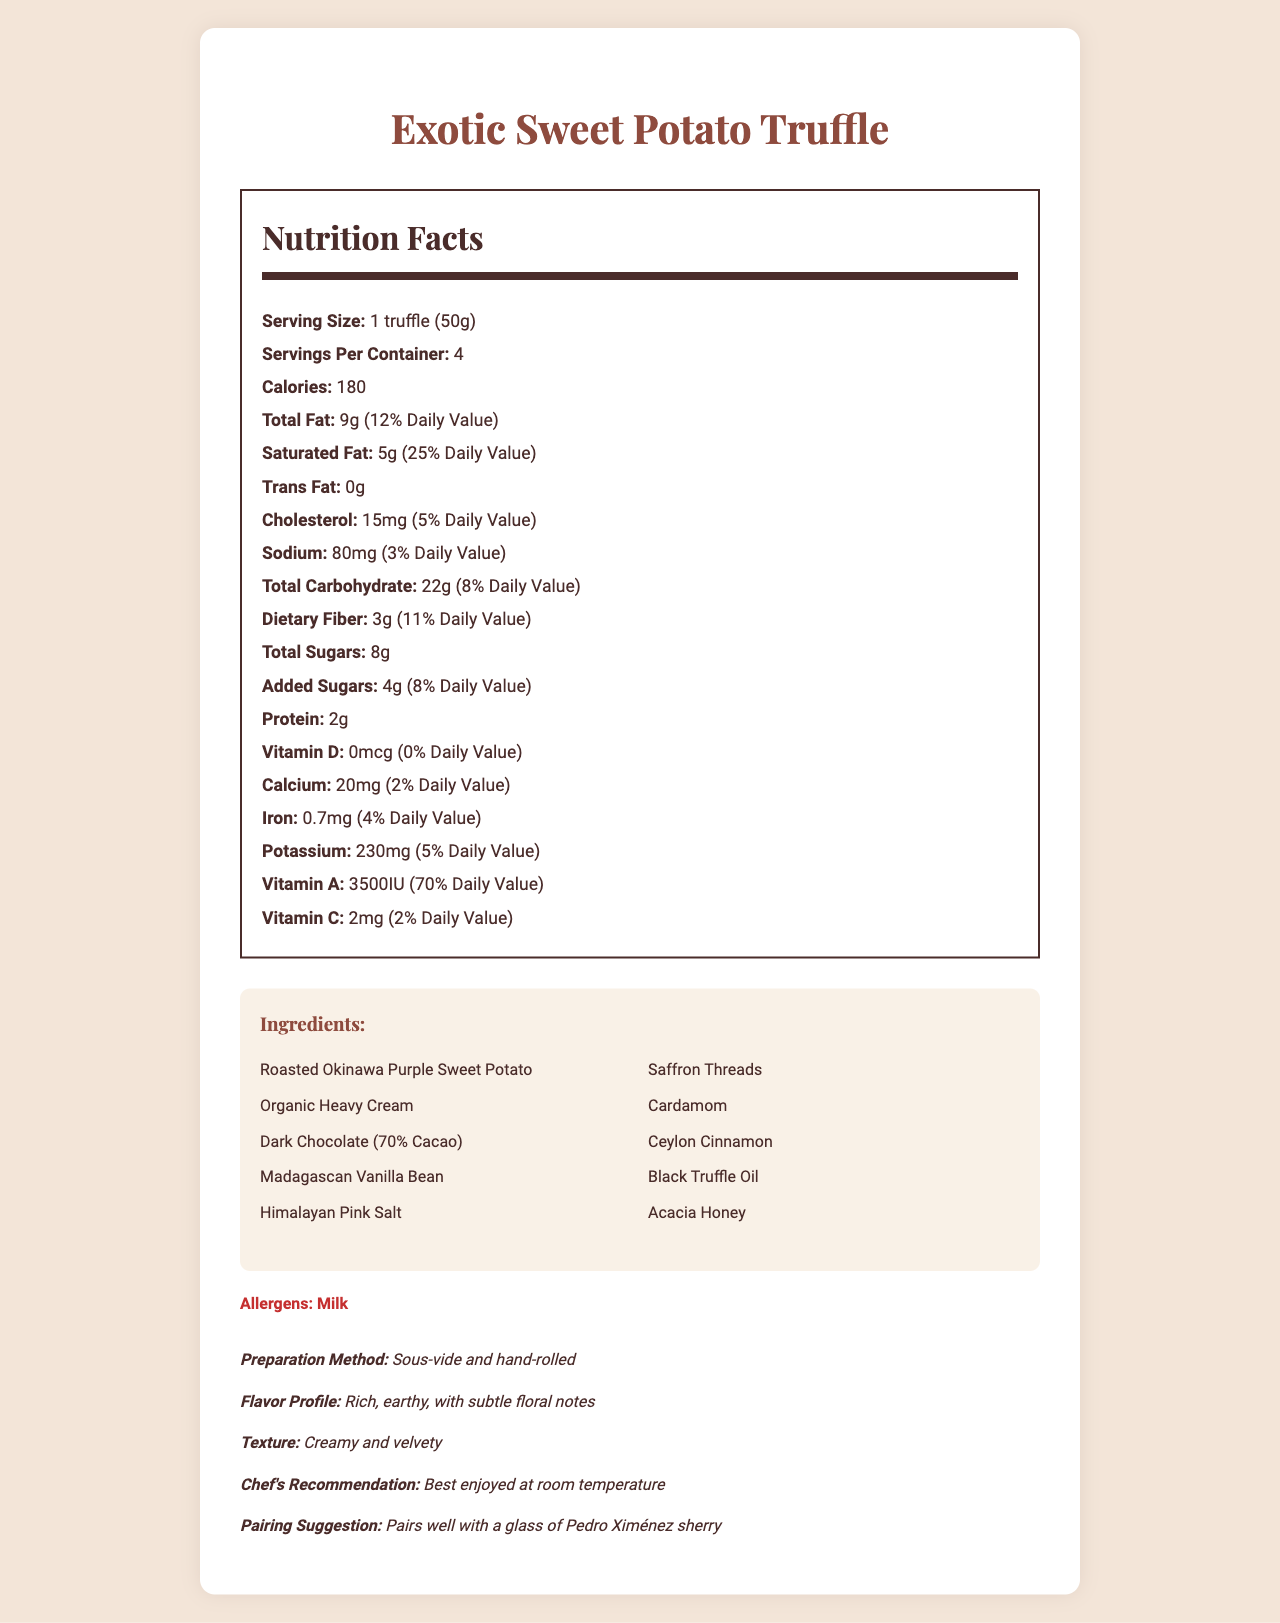what is the serving size? The serving size is specified in the Nutrition Facts section as "1 truffle (50g)."
Answer: 1 truffle (50g) how many calories are there in one serving? The calorie count per serving is mentioned in the Nutrition Facts section as 180 calories.
Answer: 180 what is the daily value percentage of saturated fat per serving? The nutrition facts indicate that saturated fat per serving contributes 25% to the daily value.
Answer: 25% how much dietary fiber is in one truffle? The document lists dietary fiber content as 3g per serving.
Answer: 3g which ingredient is used for enhancing the flavor profile? Madagascan Vanilla Bean is one of the ingredients known for enhancing flavor.
Answer: Madagascan Vanilla Bean how many servings are in one container? The document specifies that there are 4 servings per container.
Answer: 4 does the dish contain any trans fat? The trans fat content is listed as 0g.
Answer: No what is the chef's recommendation for enjoying this dish? The additional information section states that the chef recommends enjoying the dish at room temperature.
Answer: Best enjoyed at room temperature which type of milk is a potential allergen in this dish? A. Almond milk B. Cow's milk C. Soy milk D. Oat milk The allergens section lists "Milk," which generally refers to cow's milk.
Answer: B which nutrient contributes the highest percentage to the daily value? A. Calcium B. Iron C. Vitamin A D. Sodium Vitamin A contributes 70% to the daily value, which is the highest among the listed nutrients.
Answer: C does this dish have any added sugars? The nutrition facts specify that there are 4g of added sugars per serving.
Answer: Yes summarize the main details of this document. The summary covers the primary aspects of the document, focusing on the nutrition facts, ingredient list, preparation methods, and additional details provided.
Answer: The document provides the nutrition facts, ingredients, allergens, and additional information for a high-end sweet potato-based dish called "Exotic Sweet Potato Truffle." It contains detailed nutritional values, including serving size, calories, fats, carbohydrates, and vitamins. The ingredients include exotic items like black truffle oil and saffron threads, and the dish is prepared using sous-vide and hand-rolled methods. Additional insights, such as flavor profile, texture, chef recommendations, and pairing suggestions, are also provided. what is the exact amount of cholesterol in the dish? The document specifies the cholesterol amount as 15mg per serving, but to know the exact total amount in the entire dish, we need the number of truffles per container.
Answer: Not enough information 